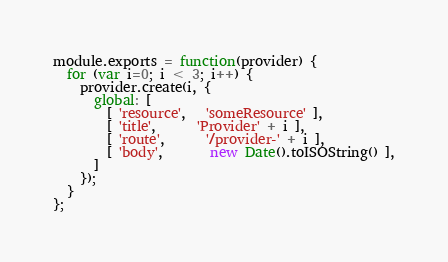<code> <loc_0><loc_0><loc_500><loc_500><_JavaScript_>module.exports = function(provider) {
  for (var i=0; i < 3; i++) {
    provider.create(i, {
      global: [
        [ 'resource',   'someResource' ],
        [ 'title',      'Provider' + i ],
        [ 'route',      '/provider-' + i ],
        [ 'body',       new Date().toISOString() ],
      ]
    });
  }
};
</code> 